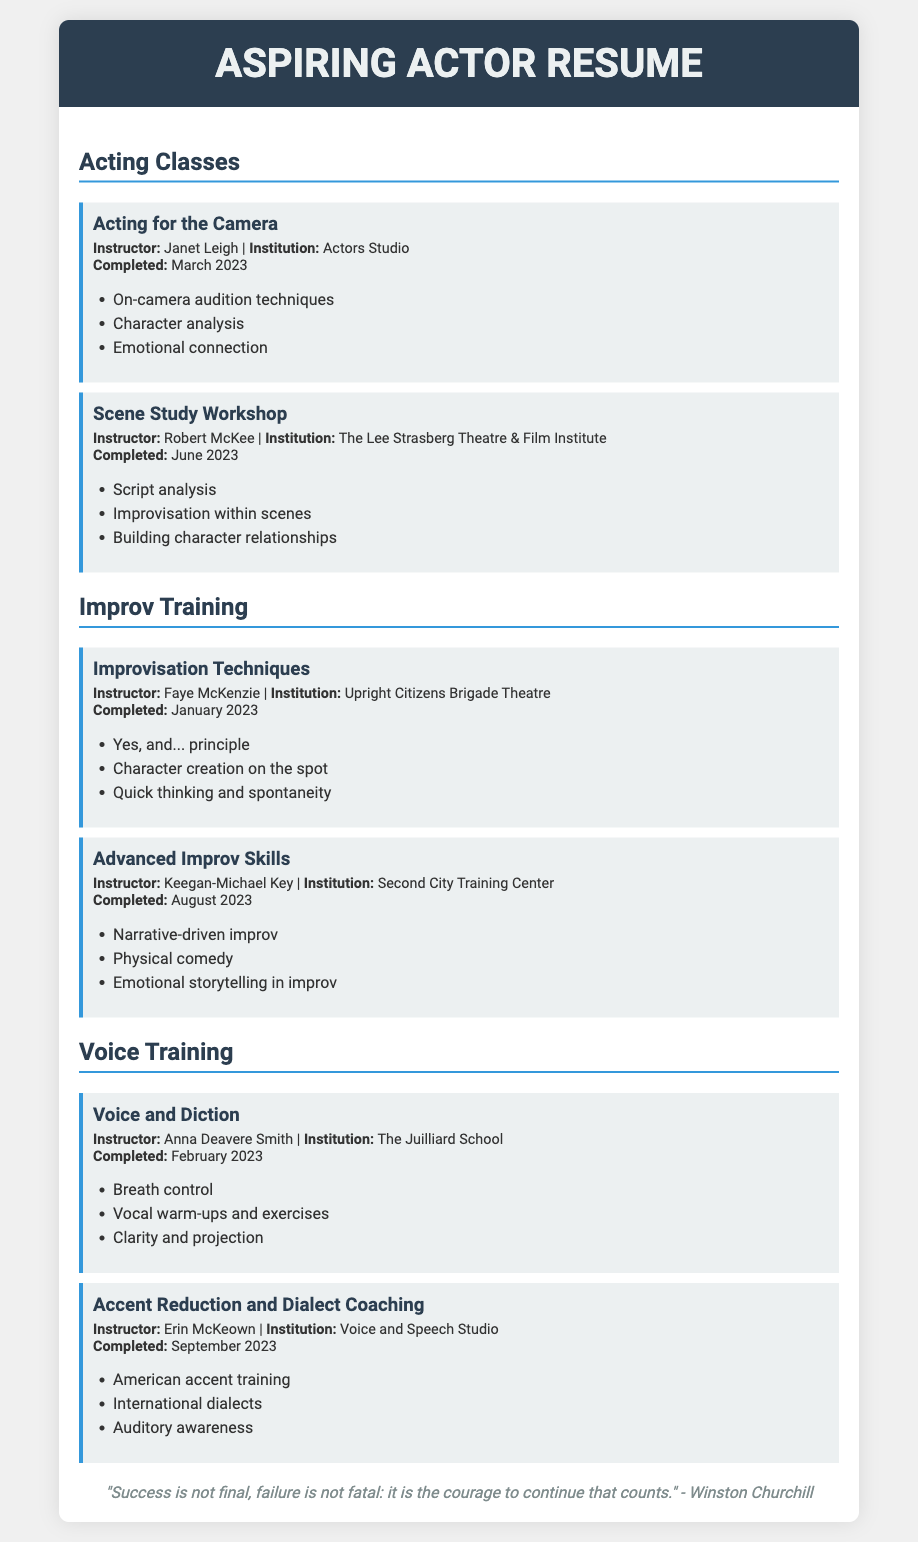What is the name of the first acting class attended? The name of the first acting class is found in the "Acting Classes" section of the document, specifically the one taught by Janet Leigh.
Answer: Acting for the Camera Who was the instructor for the Scene Study Workshop? The instructor for the Scene Study Workshop is listed in its respective course details.
Answer: Robert McKee When was the Voice and Diction course completed? The completion date for the Voice and Diction course is specified under its course information.
Answer: February 2023 What technique is associated with the Improv Training "Improvisation Techniques" course? The technique taught in the "Improvisation Techniques" course can be found in the course details and focuses on a fundamental principle of improvisation.
Answer: Yes, and... principle Which institution offered the Advanced Improv Skills course? The institution hosting the Advanced Improv Skills course is noted in the course’s description.
Answer: Second City Training Center How many courses are listed under Voice Training? The total number of courses is mentioned in the Voice Training section, which lists specific training programs.
Answer: 2 What is a key skill emphasized in the "Accent Reduction and Dialect Coaching" course? The key skill is one of the techniques highlighted in the course’s curriculum.
Answer: American accent training Who is the quoted speaker at the bottom of the resume? The speaker of the quote is identified at the end of the document.
Answer: Winston Churchill 